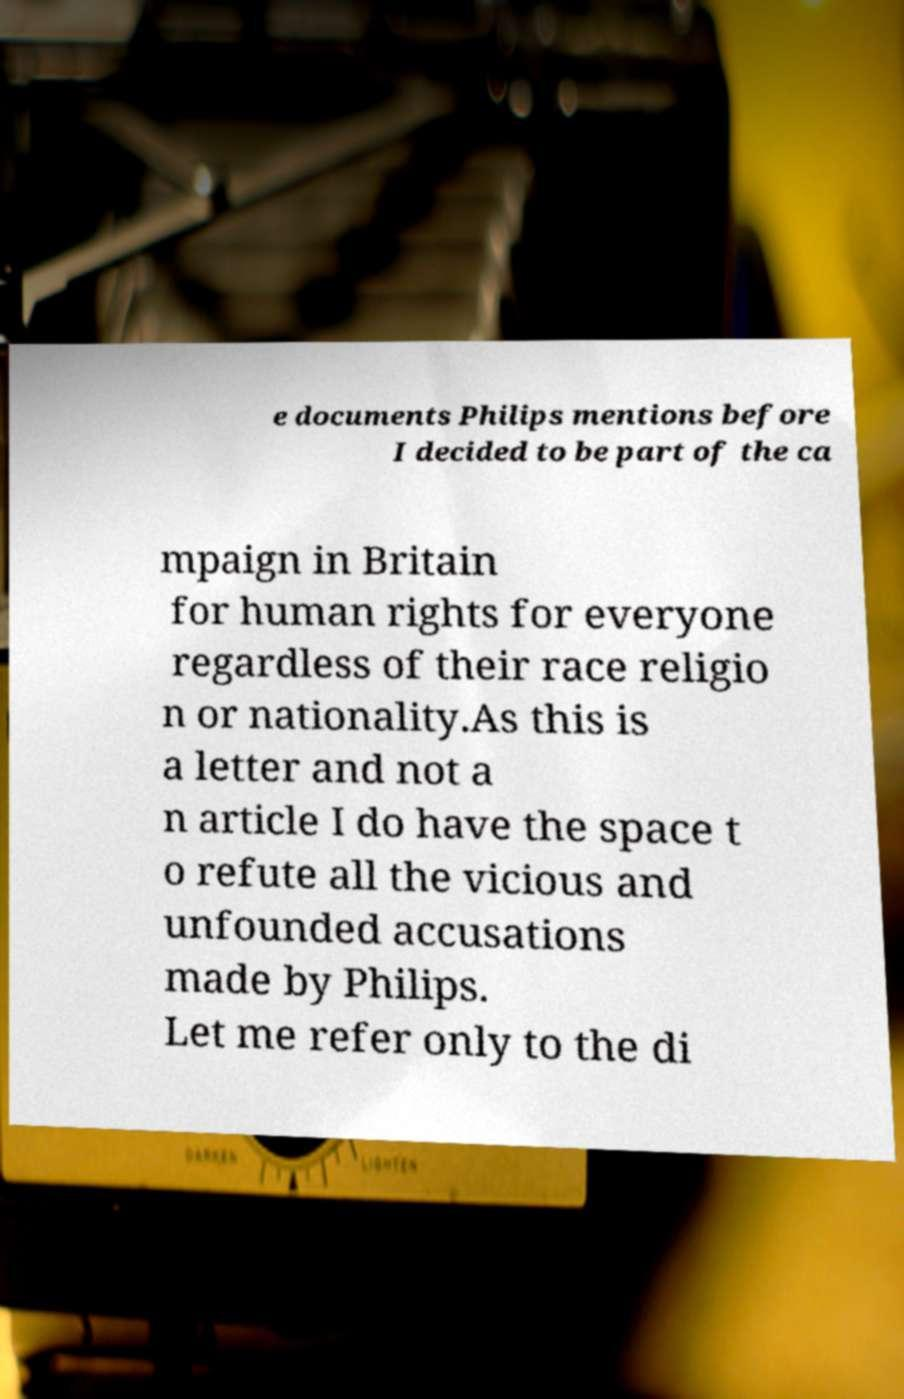Could you extract and type out the text from this image? e documents Philips mentions before I decided to be part of the ca mpaign in Britain for human rights for everyone regardless of their race religio n or nationality.As this is a letter and not a n article I do have the space t o refute all the vicious and unfounded accusations made by Philips. Let me refer only to the di 